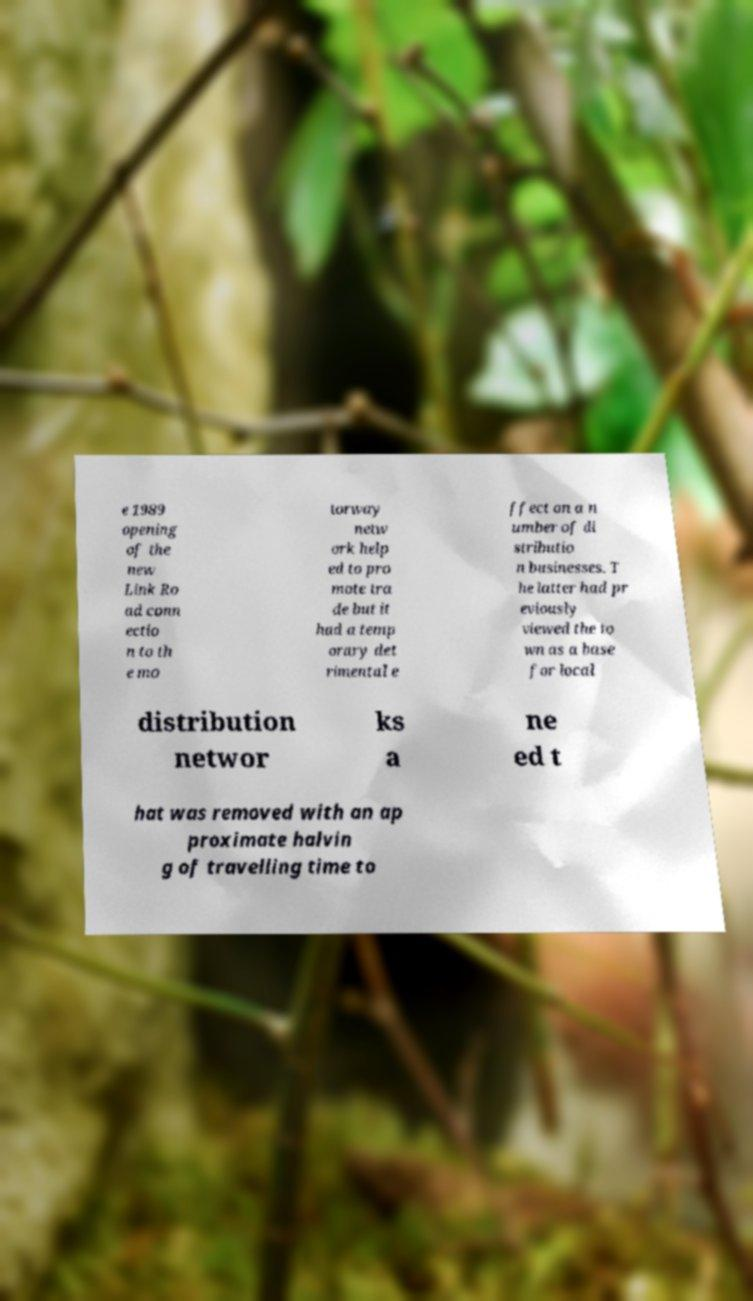Please read and relay the text visible in this image. What does it say? e 1989 opening of the new Link Ro ad conn ectio n to th e mo torway netw ork help ed to pro mote tra de but it had a temp orary det rimental e ffect on a n umber of di stributio n businesses. T he latter had pr eviously viewed the to wn as a base for local distribution networ ks a ne ed t hat was removed with an ap proximate halvin g of travelling time to 